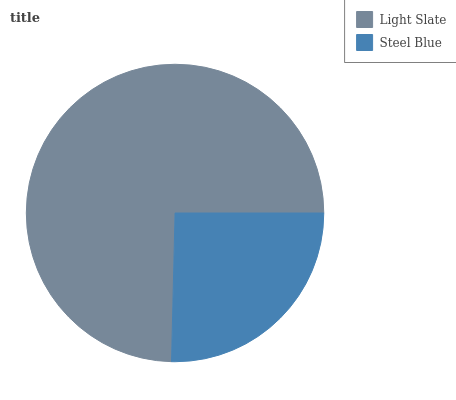Is Steel Blue the minimum?
Answer yes or no. Yes. Is Light Slate the maximum?
Answer yes or no. Yes. Is Steel Blue the maximum?
Answer yes or no. No. Is Light Slate greater than Steel Blue?
Answer yes or no. Yes. Is Steel Blue less than Light Slate?
Answer yes or no. Yes. Is Steel Blue greater than Light Slate?
Answer yes or no. No. Is Light Slate less than Steel Blue?
Answer yes or no. No. Is Light Slate the high median?
Answer yes or no. Yes. Is Steel Blue the low median?
Answer yes or no. Yes. Is Steel Blue the high median?
Answer yes or no. No. Is Light Slate the low median?
Answer yes or no. No. 